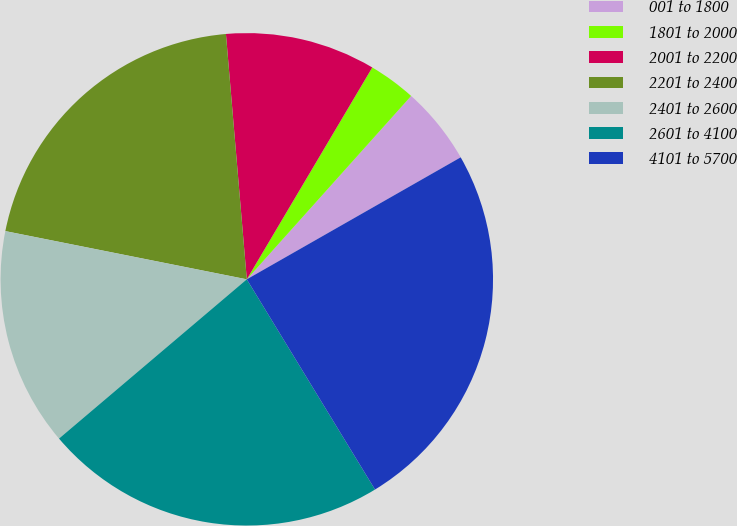Convert chart to OTSL. <chart><loc_0><loc_0><loc_500><loc_500><pie_chart><fcel>001 to 1800<fcel>1801 to 2000<fcel>2001 to 2200<fcel>2201 to 2400<fcel>2401 to 2600<fcel>2601 to 4100<fcel>4101 to 5700<nl><fcel>5.12%<fcel>3.12%<fcel>9.86%<fcel>20.51%<fcel>14.33%<fcel>22.52%<fcel>24.53%<nl></chart> 